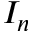Convert formula to latex. <formula><loc_0><loc_0><loc_500><loc_500>I _ { n }</formula> 